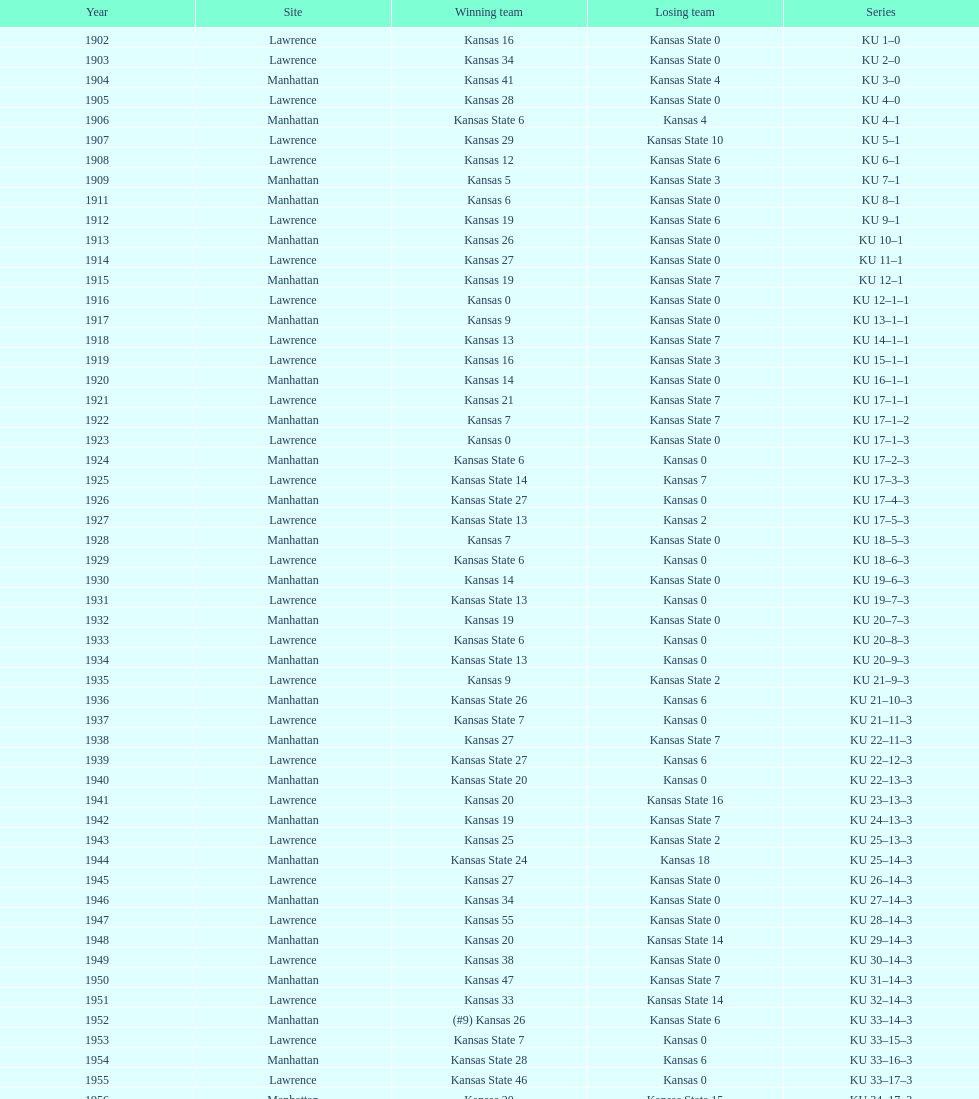When was the most recent occasion kansas state scored 0 points and lost in manhattan? 1964. 